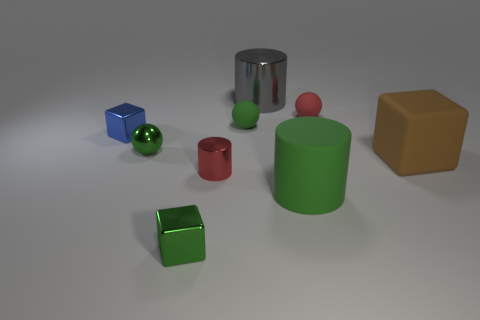How many blue things have the same size as the red ball?
Provide a short and direct response. 1. Does the small cube that is right of the tiny blue cube have the same color as the rubber thing that is in front of the big brown rubber object?
Offer a terse response. Yes. Are there any tiny green shiny spheres on the right side of the large brown thing?
Make the answer very short. No. What color is the cube that is both on the left side of the large gray cylinder and behind the green metal cube?
Offer a very short reply. Blue. Is there a small rubber sphere of the same color as the tiny cylinder?
Offer a terse response. Yes. Do the large cylinder behind the blue object and the red thing to the right of the large green cylinder have the same material?
Give a very brief answer. No. There is a cube that is to the right of the green rubber cylinder; what size is it?
Keep it short and to the point. Large. The gray metallic thing is what size?
Ensure brevity in your answer.  Large. There is a metal cylinder behind the rubber object on the right side of the ball right of the big green rubber thing; what size is it?
Offer a terse response. Large. Is there a big brown block made of the same material as the large brown thing?
Provide a succinct answer. No. 